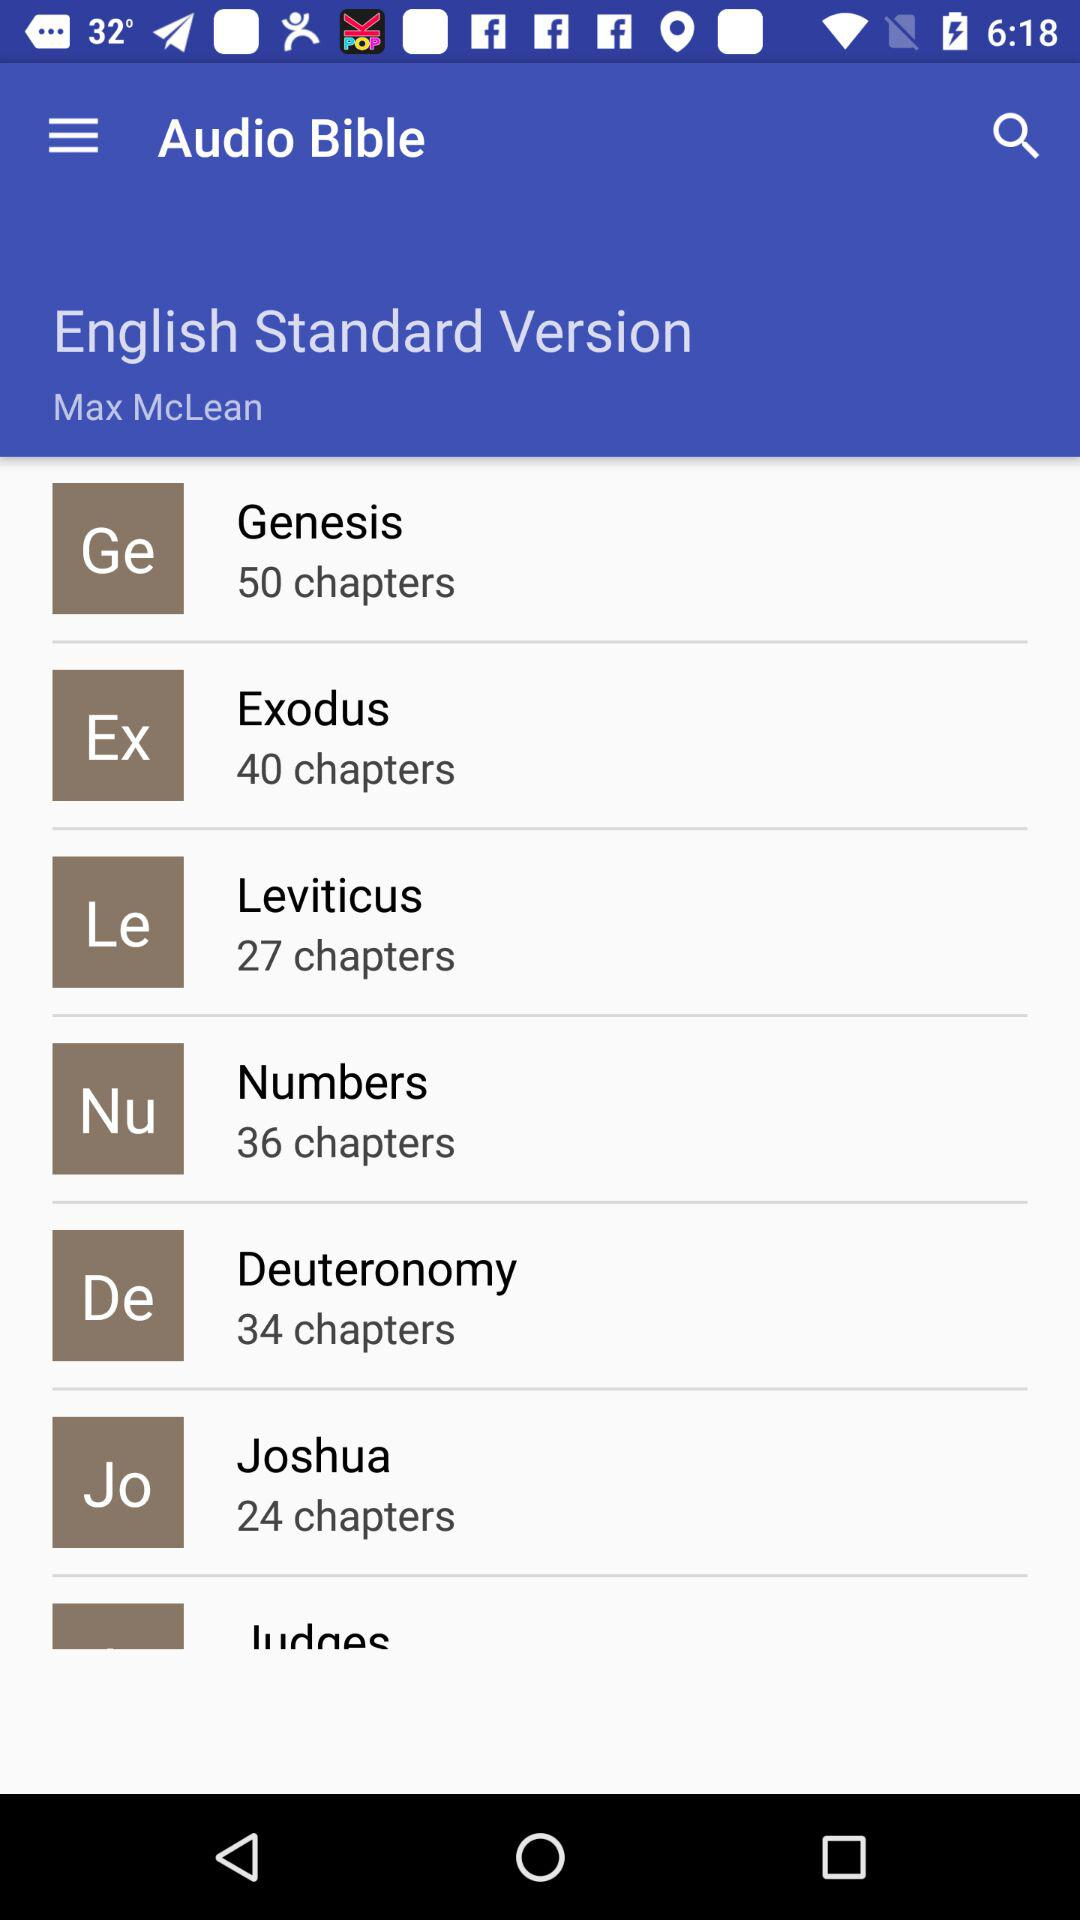What is the application name? The application name is "Audio Bible". 